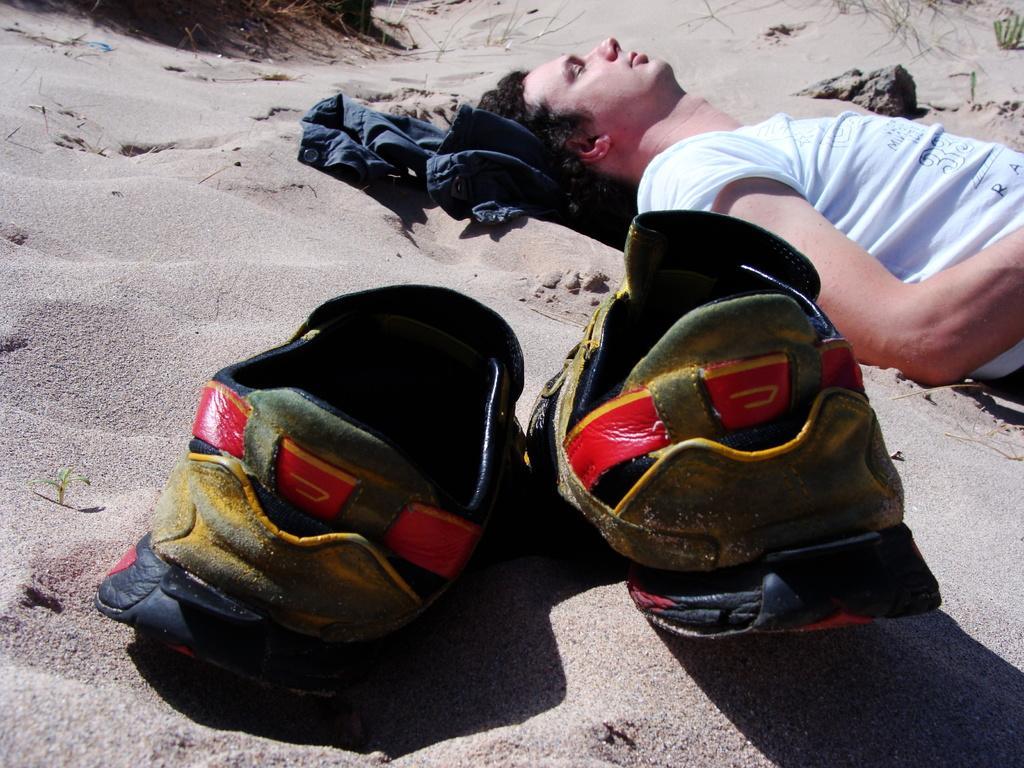Could you give a brief overview of what you see in this image? In this picture I can observe a man laying on the sand. In the middle of the picture I can observe a pair of shoes. 